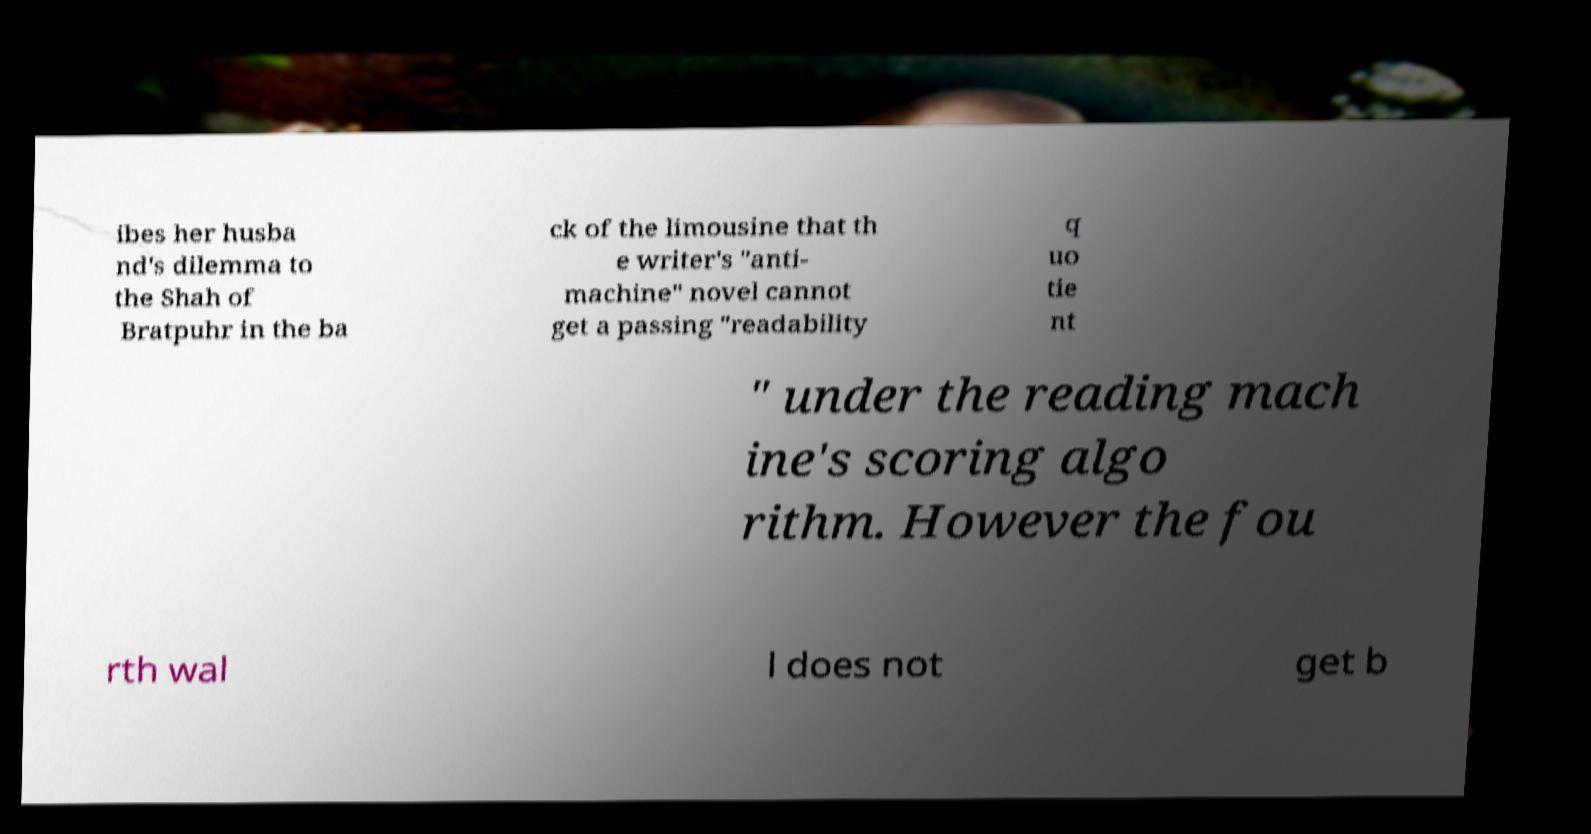Can you read and provide the text displayed in the image?This photo seems to have some interesting text. Can you extract and type it out for me? ibes her husba nd's dilemma to the Shah of Bratpuhr in the ba ck of the limousine that th e writer's "anti- machine" novel cannot get a passing "readability q uo tie nt " under the reading mach ine's scoring algo rithm. However the fou rth wal l does not get b 